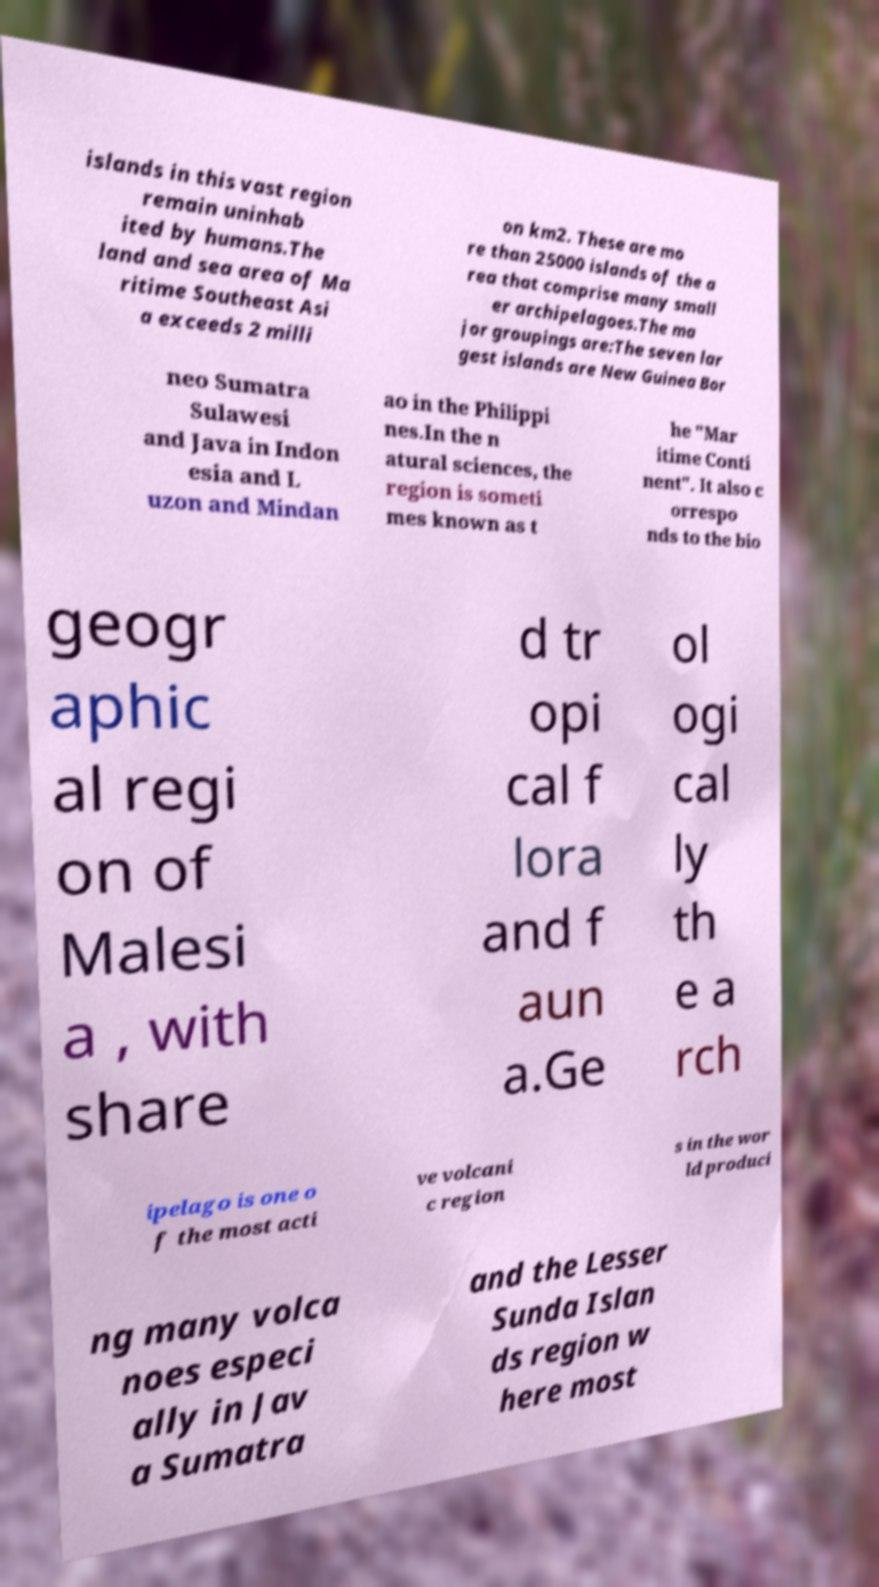Can you read and provide the text displayed in the image?This photo seems to have some interesting text. Can you extract and type it out for me? islands in this vast region remain uninhab ited by humans.The land and sea area of Ma ritime Southeast Asi a exceeds 2 milli on km2. These are mo re than 25000 islands of the a rea that comprise many small er archipelagoes.The ma jor groupings are:The seven lar gest islands are New Guinea Bor neo Sumatra Sulawesi and Java in Indon esia and L uzon and Mindan ao in the Philippi nes.In the n atural sciences, the region is someti mes known as t he "Mar itime Conti nent". It also c orrespo nds to the bio geogr aphic al regi on of Malesi a , with share d tr opi cal f lora and f aun a.Ge ol ogi cal ly th e a rch ipelago is one o f the most acti ve volcani c region s in the wor ld produci ng many volca noes especi ally in Jav a Sumatra and the Lesser Sunda Islan ds region w here most 